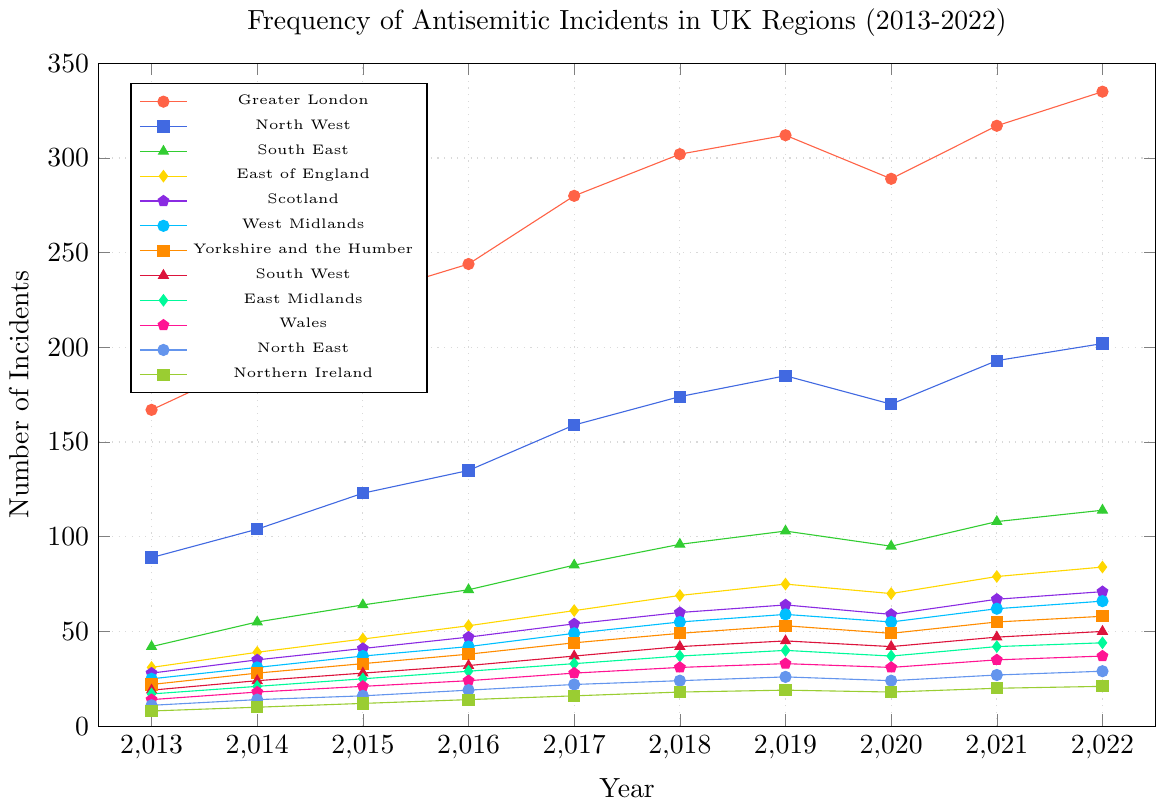Which region had the highest number of antisemitic incidents in 2022? The dot plot shows Greater London with the highest number of incidents in 2022, indicated by the highest position on the vertical scale for that year.
Answer: Greater London How many more incidents were reported in the North West in 2022 compared to 2013? The North West had 202 incidents in 2022 and 89 incidents in 2013. Subtracting the former from the latter gives 202 - 89.
Answer: 113 On average, how many incidents were reported annually in the East Midlands between 2013 and 2022? First sum the incidents in the East Midlands for each year (17+21+25+29+33+37+40+37+42+44), which is 325, then divide by 10 to get the annual average.
Answer: 32.5 Which regions had fewer antisemitic incidents than Scotland in 2021? Scotland had 67 incidents in 2021. Looking at the plot, Northern Ireland, North East, Wales, East Midlands, South West, and Yorkshire and the Humber all had fewer incidents than Scotland.
Answer: Northern Ireland, North East, Wales, East Midlands, South West, Yorkshire and the Humber By how much did antisemitic incidents increase in Greater London from 2019 to 2022? In Greater London, incidents were 312 in 2019 and 335 in 2022. The increase is 335 - 312.
Answer: 23 Which region showed no increase in incidents from 2019 to 2020? The West Midlands had 59 incidents in both 2019 and 2020, showing no increase.
Answer: West Midlands Which region had the smallest overall increase in incidents from 2013 to 2022? Look at the difference from 2013 to 2022 for each region. Northern Ireland had only an increase from 8 to 21, which is the smallest increase.
Answer: Northern Ireland Rank the regions based on the number of incidents reported in 2020 from highest to lowest. The plot shows the number of incidents for each region in 2020. By visually comparing their positions, the ranking is: Greater London, North West, South East, East of England, Scotland, West Midlands, Yorkshire and the Humber, South West, East Midlands, Wales, North East, Northern Ireland.
Answer: Greater London, North West, South East, East of England, Scotland, West Midlands, Yorkshire and the Humber, South West, East Midlands, Wales, North East, Northern Ireland Which region experienced the biggest drop in incidents between 2019 and 2020? The North West had 185 incidents in 2019 and 170 in 2020, a drop of 15, which is the largest drop among all regions.
Answer: North West What was the total number of antisemitic incidents reported across all regions in 2017? Sum the number of incidents in each region for 2017 (280+159+85+61+54+49+44+37+33+28+22+16).
Answer: 868 